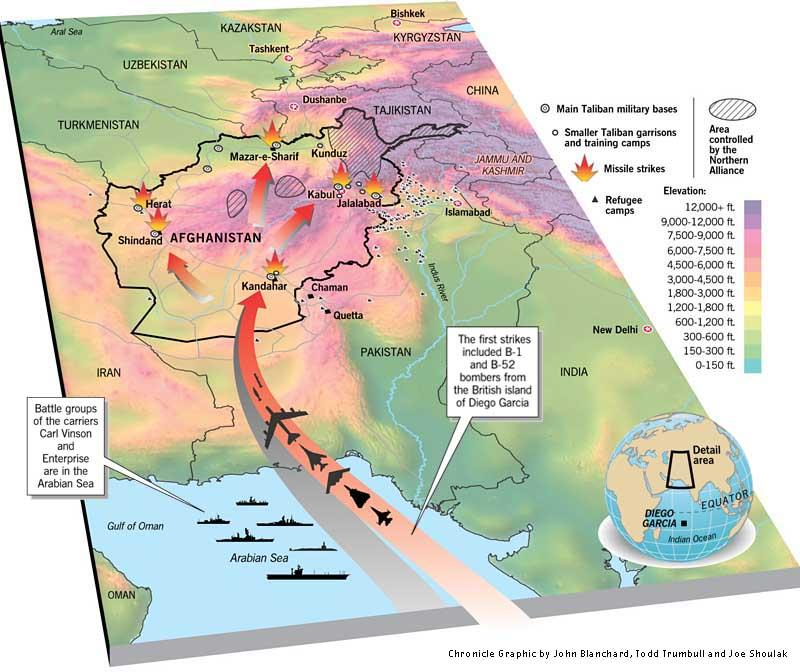Point out several critical features in this image. There are currently 8 known main Taliban military bases located in Afghanistan. Five missile strikes were made. The first strike was carried out using B-1 and B-52 bombers. There is only one refugee camp in Kandahar. The target of the missiles was Taliban military bases, not Taliban garrisons. 